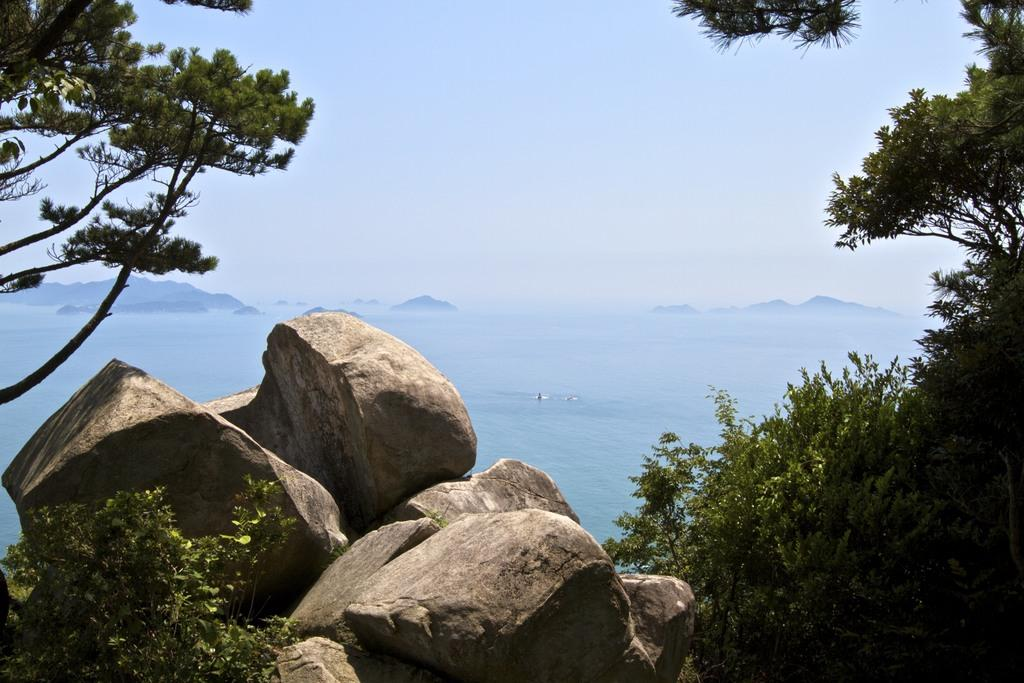What type of natural elements can be seen in the image? There are trees, rocks, and water visible in the image. What type of landscape feature is present in the image? There are hills in the image. What is visible in the background of the image? The sky is visible in the image. What type of cakes can be seen in the image? There are no cakes present in the image; it features natural elements such as trees, rocks, water, hills, and the sky. Can you see a kitten playing among the trees in the image? There is no kitten present in the image; it only features natural elements and the sky. 